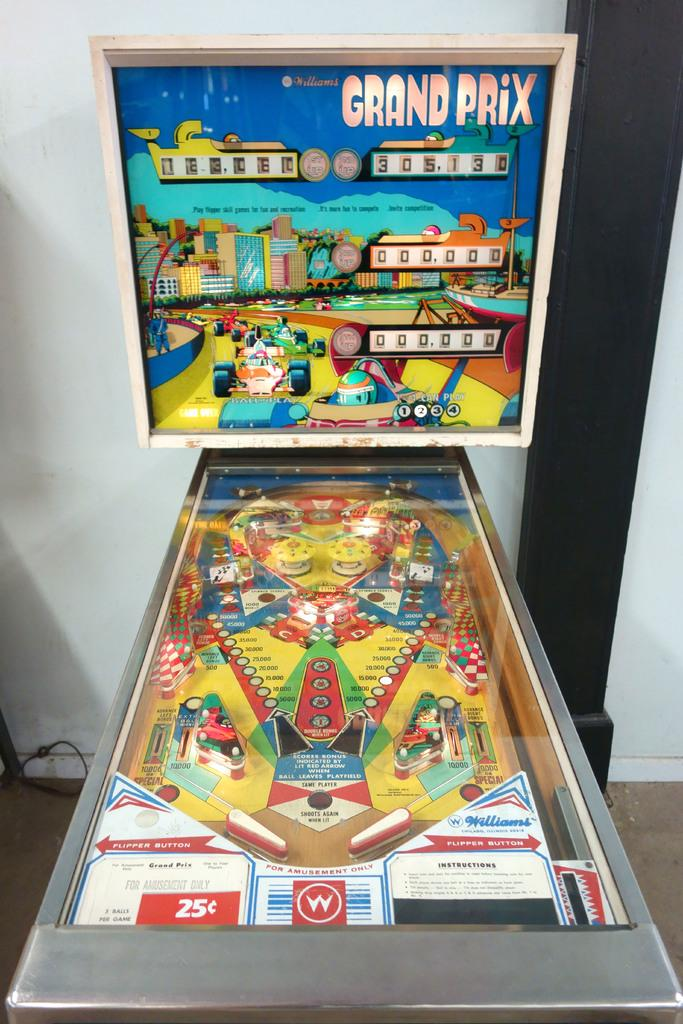What type of objects can be seen on the game boards in the image? The specific details of the game boards are not mentioned, so we cannot determine what type of objects are on them. What is depicted on the posters in the image? The specific content of the posters is not mentioned, so we cannot determine what is depicted on them. What can be seen on the floor in the image? The floor is visible in the image, but no specific details are mentioned about what is on it. What is the purpose of the wall in the image? The purpose of the wall is not mentioned, but it serves as a structural element in the space. What is the function of the pillar in the image? The function of the pillar is not mentioned, but it likely provides support for the structure. Can you tell me where the locket is hidden in the image? There is no mention of a locket in the image, so we cannot determine its location. What type of pest can be seen crawling on the game boards in the image? There is no mention of any pests in the image, so we cannot determine if any are present. 